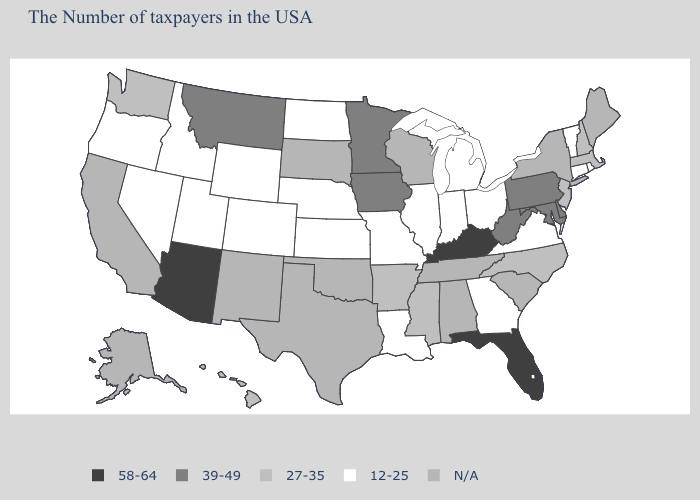Does Iowa have the lowest value in the USA?
Answer briefly. No. What is the highest value in the USA?
Write a very short answer. 58-64. What is the highest value in the USA?
Short answer required. 58-64. Which states have the highest value in the USA?
Answer briefly. Florida, Kentucky, Arizona. What is the lowest value in states that border Massachusetts?
Be succinct. 12-25. What is the value of Colorado?
Short answer required. 12-25. Which states hav the highest value in the South?
Concise answer only. Florida, Kentucky. Name the states that have a value in the range 27-35?
Keep it brief. Massachusetts, New Hampshire, New Jersey, North Carolina, Mississippi, Arkansas, Washington, Hawaii. What is the value of Rhode Island?
Give a very brief answer. 12-25. Which states hav the highest value in the West?
Quick response, please. Arizona. Does Virginia have the lowest value in the South?
Be succinct. Yes. What is the lowest value in the USA?
Write a very short answer. 12-25. What is the value of Alaska?
Keep it brief. N/A. 